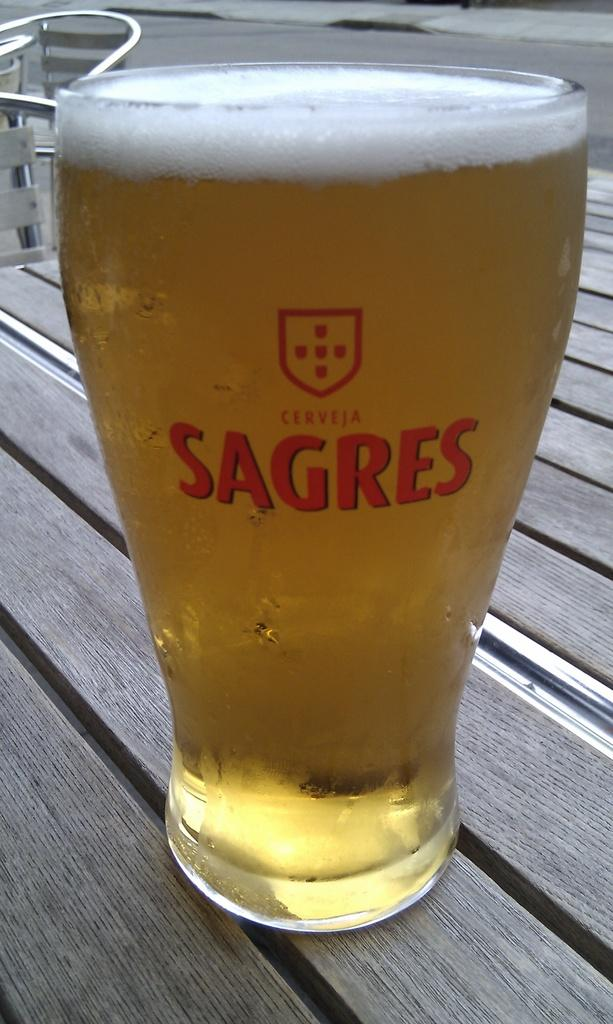What is in the glass that is visible in the image? There is a drink in the glass in the image. Where is the glass located in the image? The glass is on a platform in the image. What can be seen in the background of the image? There are chairs in the background of the image. How many ducks are sitting on the pencil in the image? There are no ducks or pencils present in the image. 